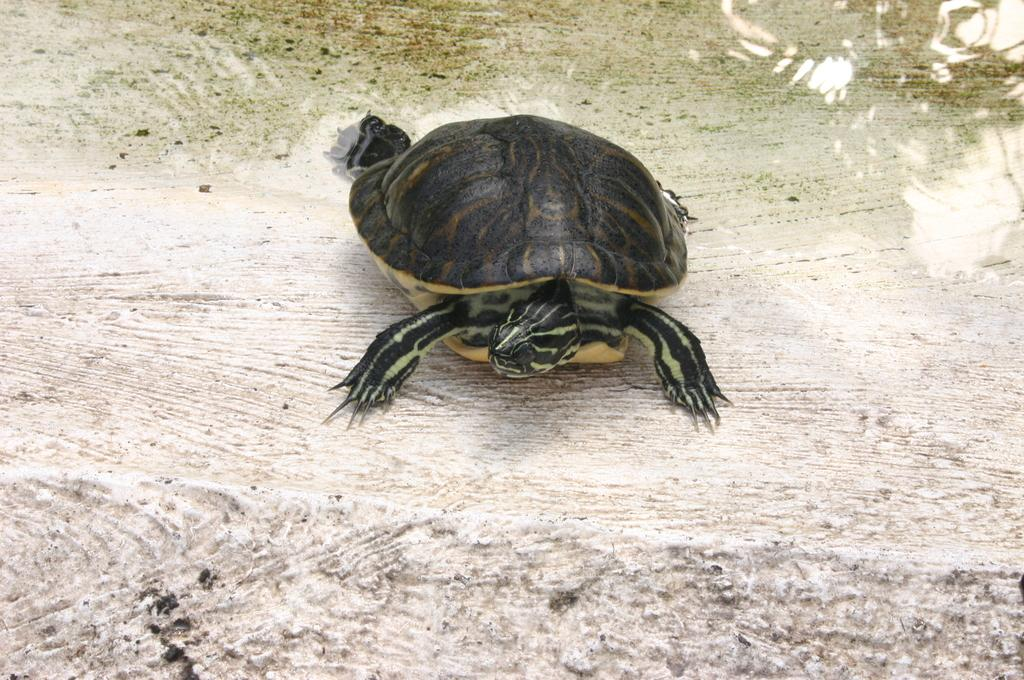What animal is present in the image? There is a tortoise in the image. Where is the tortoise located? The tortoise is in a water body. What part of the tortoise can be seen in the image? The head of the tortoise is visible. What type of feast is the toad attending in the image? There is no toad or feast present in the image; it features a tortoise in a water body. What kind of trouble is the tortoise causing in the image? There is no indication of the tortoise causing any trouble in the image. 